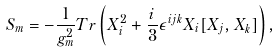Convert formula to latex. <formula><loc_0><loc_0><loc_500><loc_500>S _ { m } = - \frac { 1 } { g _ { m } ^ { 2 } } T r \left ( X _ { i } ^ { 2 } + \frac { i } { 3 } \epsilon ^ { i j k } X _ { i } [ X _ { j } , X _ { k } ] \right ) ,</formula> 